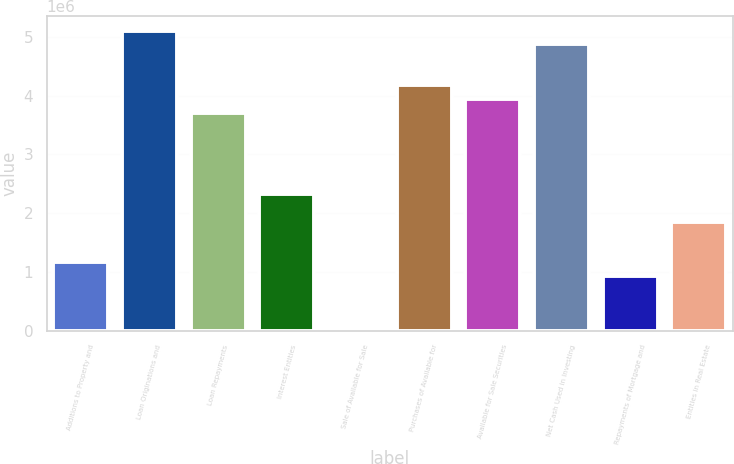Convert chart to OTSL. <chart><loc_0><loc_0><loc_500><loc_500><bar_chart><fcel>Additions to Property and<fcel>Loan Originations and<fcel>Loan Repayments<fcel>Interest Entities<fcel>Sale of Available for Sale<fcel>Purchases of Available for<fcel>Available for Sale Securities<fcel>Net Cash Used in Investing<fcel>Repayments of Mortgage and<fcel>Entities in Real Estate<nl><fcel>1.15954e+06<fcel>5.10113e+06<fcel>3.70998e+06<fcel>2.31883e+06<fcel>252<fcel>4.17369e+06<fcel>3.94184e+06<fcel>4.86927e+06<fcel>927684<fcel>1.85512e+06<nl></chart> 